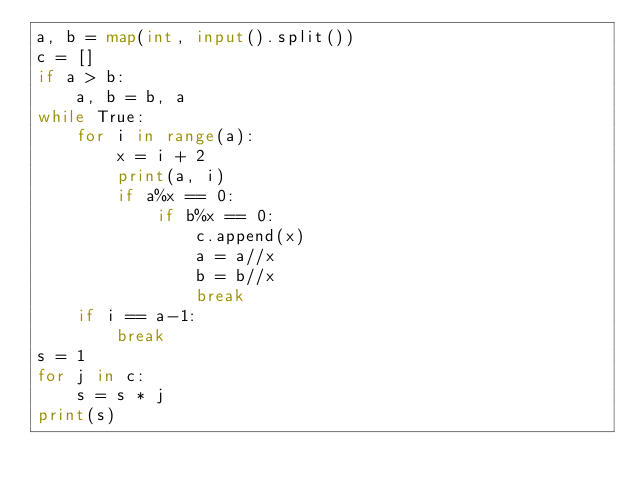Convert code to text. <code><loc_0><loc_0><loc_500><loc_500><_Python_>a, b = map(int, input().split())
c = []
if a > b:
    a, b = b, a
while True:
    for i in range(a):
        x = i + 2
        print(a, i)
        if a%x == 0:
            if b%x == 0:
                c.append(x)
                a = a//x
                b = b//x
                break
    if i == a-1:
        break
s = 1
for j in c:
    s = s * j
print(s)

</code> 